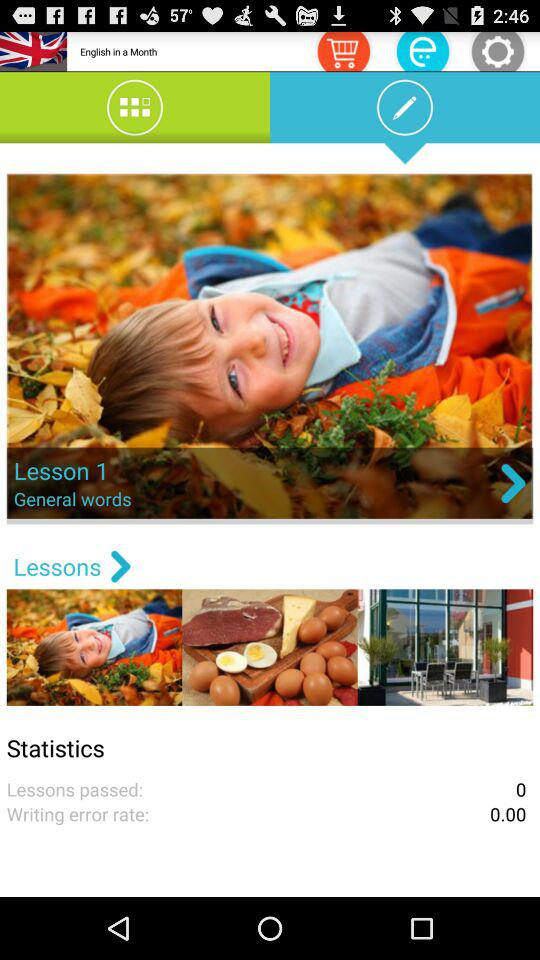What is the name of the lesson? The name of the lesson is "General words". 